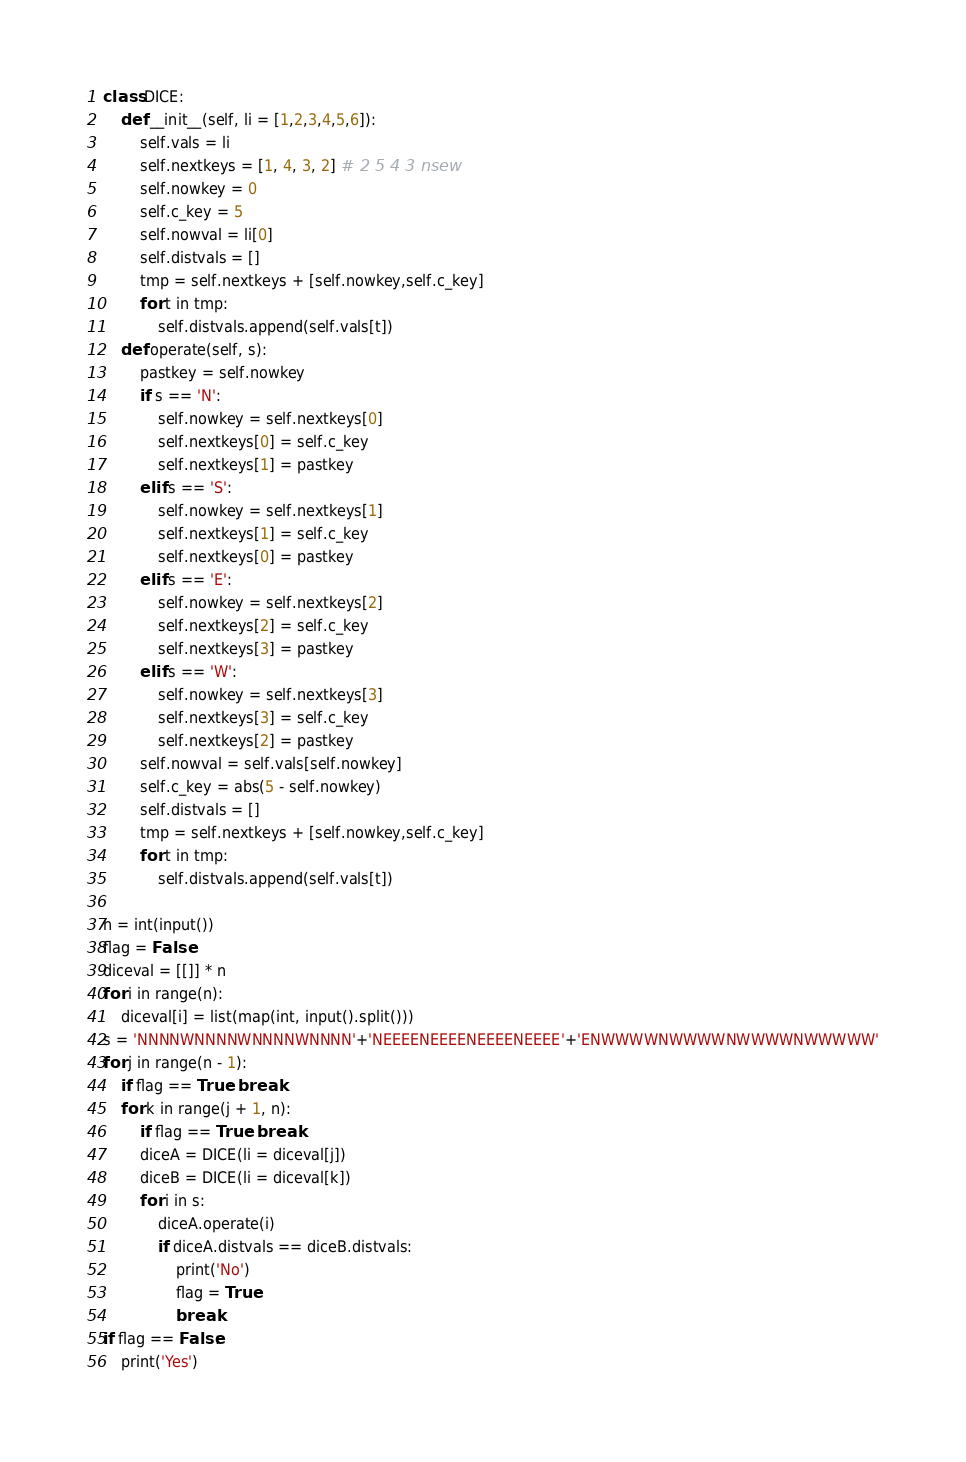<code> <loc_0><loc_0><loc_500><loc_500><_Python_>class DICE:
    def __init__(self, li = [1,2,3,4,5,6]):
        self.vals = li
        self.nextkeys = [1, 4, 3, 2] # 2 5 4 3 nsew
        self.nowkey = 0
        self.c_key = 5
        self.nowval = li[0]
        self.distvals = []
        tmp = self.nextkeys + [self.nowkey,self.c_key]
        for t in tmp:
            self.distvals.append(self.vals[t]) 
    def operate(self, s):
        pastkey = self.nowkey
        if s == 'N':
            self.nowkey = self.nextkeys[0]
            self.nextkeys[0] = self.c_key
            self.nextkeys[1] = pastkey
        elif s == 'S':
            self.nowkey = self.nextkeys[1]
            self.nextkeys[1] = self.c_key
            self.nextkeys[0] = pastkey
        elif s == 'E':
            self.nowkey = self.nextkeys[2]
            self.nextkeys[2] = self.c_key
            self.nextkeys[3] = pastkey
        elif s == 'W':
            self.nowkey = self.nextkeys[3]
            self.nextkeys[3] = self.c_key
            self.nextkeys[2] = pastkey
        self.nowval = self.vals[self.nowkey]
        self.c_key = abs(5 - self.nowkey)
        self.distvals = []
        tmp = self.nextkeys + [self.nowkey,self.c_key]
        for t in tmp:
            self.distvals.append(self.vals[t]) 

n = int(input())
flag = False
diceval = [[]] * n
for i in range(n):
    diceval[i] = list(map(int, input().split()))
s = 'NNNNWNNNNWNNNNWNNNN'+'NEEEENEEEENEEEENEEEE'+'ENWWWWNWWWWNWWWWNWWWWW'
for j in range(n - 1):
    if flag == True: break
    for k in range(j + 1, n):
        if flag == True: break
        diceA = DICE(li = diceval[j])
        diceB = DICE(li = diceval[k])
        for i in s:
            diceA.operate(i)
            if diceA.distvals == diceB.distvals:
                print('No')
                flag = True
                break
if flag == False:
    print('Yes')

</code> 